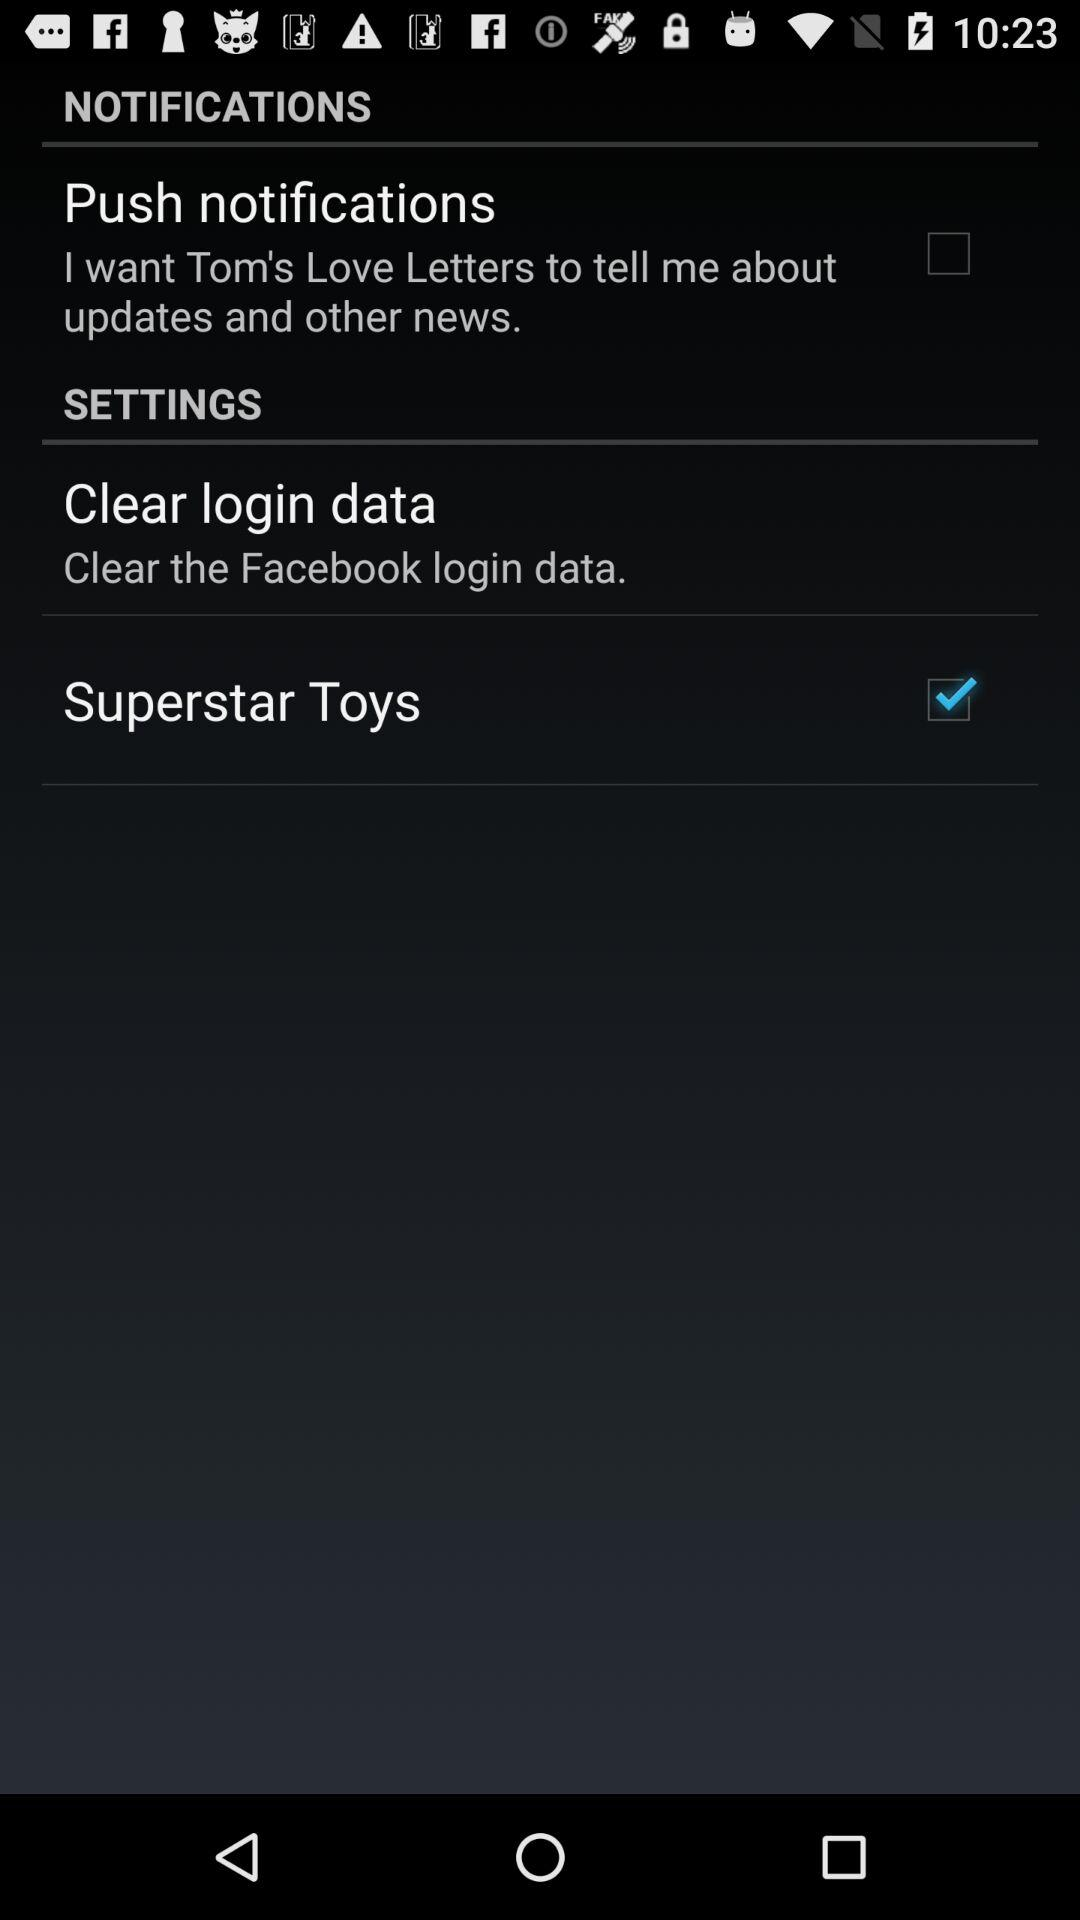How's the update and other news obtained? The update and other news are obtained through Tom's Love Letters. 